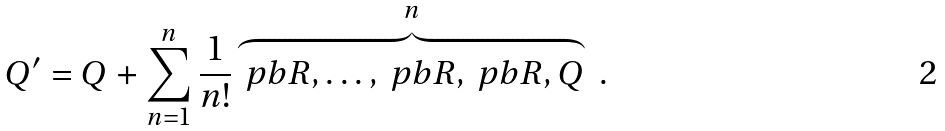<formula> <loc_0><loc_0><loc_500><loc_500>Q ^ { \prime } = Q + \sum _ { n = 1 } ^ { n } \frac { 1 } { n ! } \overbrace { \ p b { R , \dots , \ p b { R , \ p b { R , Q } } } } ^ { n } \ .</formula> 